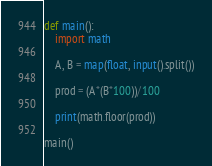<code> <loc_0><loc_0><loc_500><loc_500><_Python_>def main():
    import math

    A, B = map(float, input().split())

    prod = (A*(B*100))/100

    print(math.floor(prod))

main()</code> 